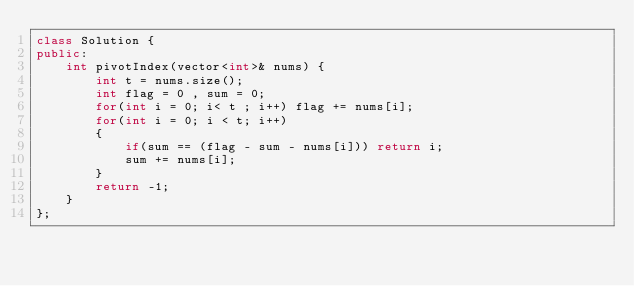Convert code to text. <code><loc_0><loc_0><loc_500><loc_500><_C++_>class Solution {
public:
    int pivotIndex(vector<int>& nums) {
        int t = nums.size();
        int flag = 0 , sum = 0;
        for(int i = 0; i< t ; i++) flag += nums[i];
        for(int i = 0; i < t; i++)
        {
            if(sum == (flag - sum - nums[i])) return i;
            sum += nums[i];
        }
        return -1;
    }
};
</code> 